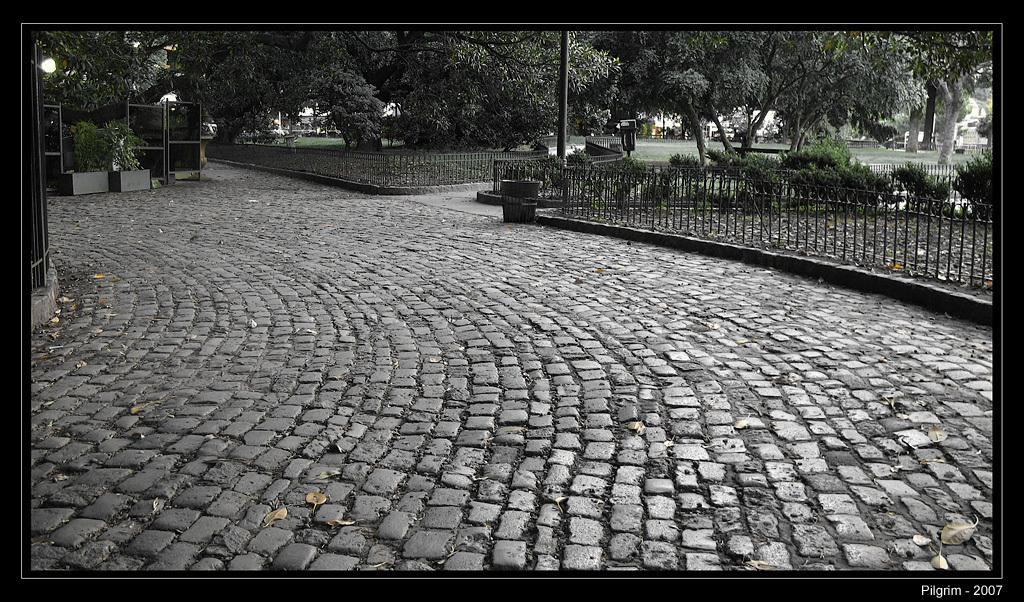Please provide a concise description of this image. This is an edited image. I can see the iron grilles, plants, and trees. At the top left side of the image, these are looking like the boards and two flower pots with plants. I can see a dustbin on the pathway. At the bottom right side of the image, I can see the watermark. 